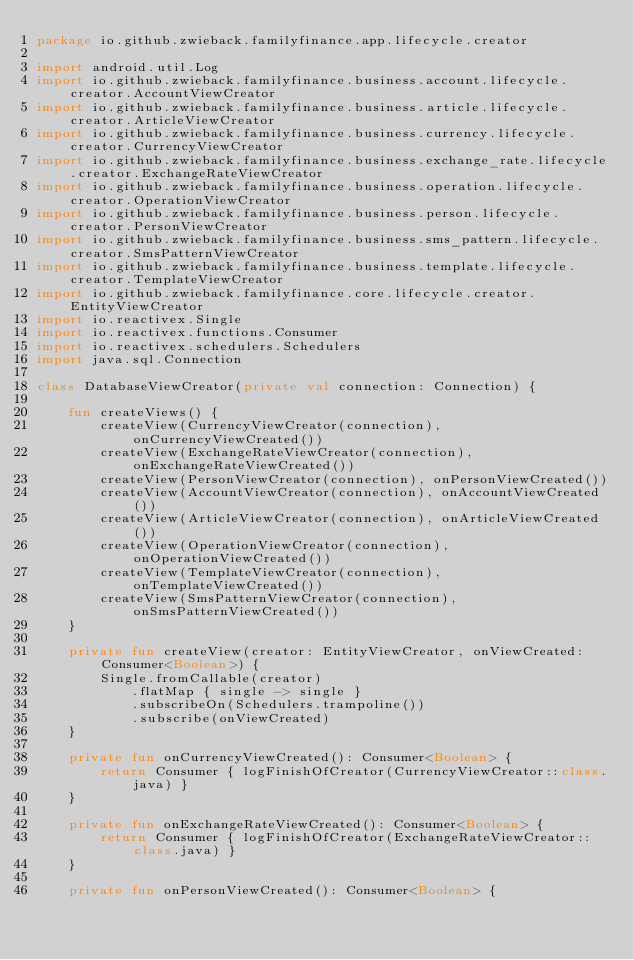<code> <loc_0><loc_0><loc_500><loc_500><_Kotlin_>package io.github.zwieback.familyfinance.app.lifecycle.creator

import android.util.Log
import io.github.zwieback.familyfinance.business.account.lifecycle.creator.AccountViewCreator
import io.github.zwieback.familyfinance.business.article.lifecycle.creator.ArticleViewCreator
import io.github.zwieback.familyfinance.business.currency.lifecycle.creator.CurrencyViewCreator
import io.github.zwieback.familyfinance.business.exchange_rate.lifecycle.creator.ExchangeRateViewCreator
import io.github.zwieback.familyfinance.business.operation.lifecycle.creator.OperationViewCreator
import io.github.zwieback.familyfinance.business.person.lifecycle.creator.PersonViewCreator
import io.github.zwieback.familyfinance.business.sms_pattern.lifecycle.creator.SmsPatternViewCreator
import io.github.zwieback.familyfinance.business.template.lifecycle.creator.TemplateViewCreator
import io.github.zwieback.familyfinance.core.lifecycle.creator.EntityViewCreator
import io.reactivex.Single
import io.reactivex.functions.Consumer
import io.reactivex.schedulers.Schedulers
import java.sql.Connection

class DatabaseViewCreator(private val connection: Connection) {

    fun createViews() {
        createView(CurrencyViewCreator(connection), onCurrencyViewCreated())
        createView(ExchangeRateViewCreator(connection), onExchangeRateViewCreated())
        createView(PersonViewCreator(connection), onPersonViewCreated())
        createView(AccountViewCreator(connection), onAccountViewCreated())
        createView(ArticleViewCreator(connection), onArticleViewCreated())
        createView(OperationViewCreator(connection), onOperationViewCreated())
        createView(TemplateViewCreator(connection), onTemplateViewCreated())
        createView(SmsPatternViewCreator(connection), onSmsPatternViewCreated())
    }

    private fun createView(creator: EntityViewCreator, onViewCreated: Consumer<Boolean>) {
        Single.fromCallable(creator)
            .flatMap { single -> single }
            .subscribeOn(Schedulers.trampoline())
            .subscribe(onViewCreated)
    }

    private fun onCurrencyViewCreated(): Consumer<Boolean> {
        return Consumer { logFinishOfCreator(CurrencyViewCreator::class.java) }
    }

    private fun onExchangeRateViewCreated(): Consumer<Boolean> {
        return Consumer { logFinishOfCreator(ExchangeRateViewCreator::class.java) }
    }

    private fun onPersonViewCreated(): Consumer<Boolean> {</code> 